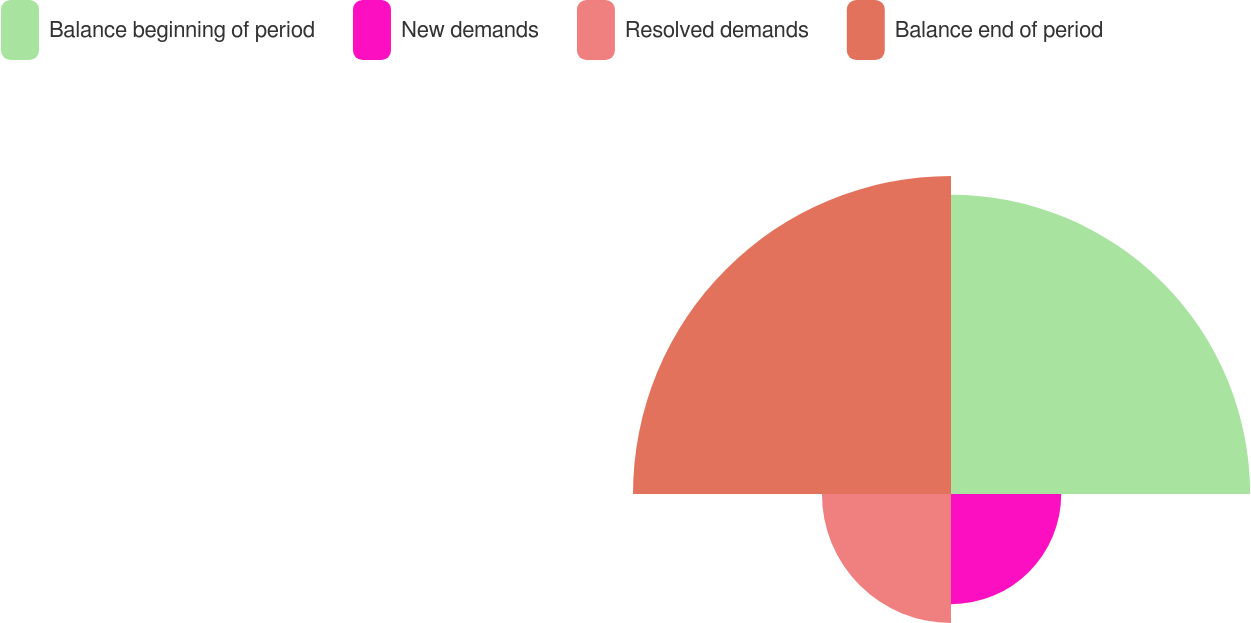Convert chart. <chart><loc_0><loc_0><loc_500><loc_500><pie_chart><fcel>Balance beginning of period<fcel>New demands<fcel>Resolved demands<fcel>Balance end of period<nl><fcel>34.93%<fcel>12.87%<fcel>15.07%<fcel>37.13%<nl></chart> 